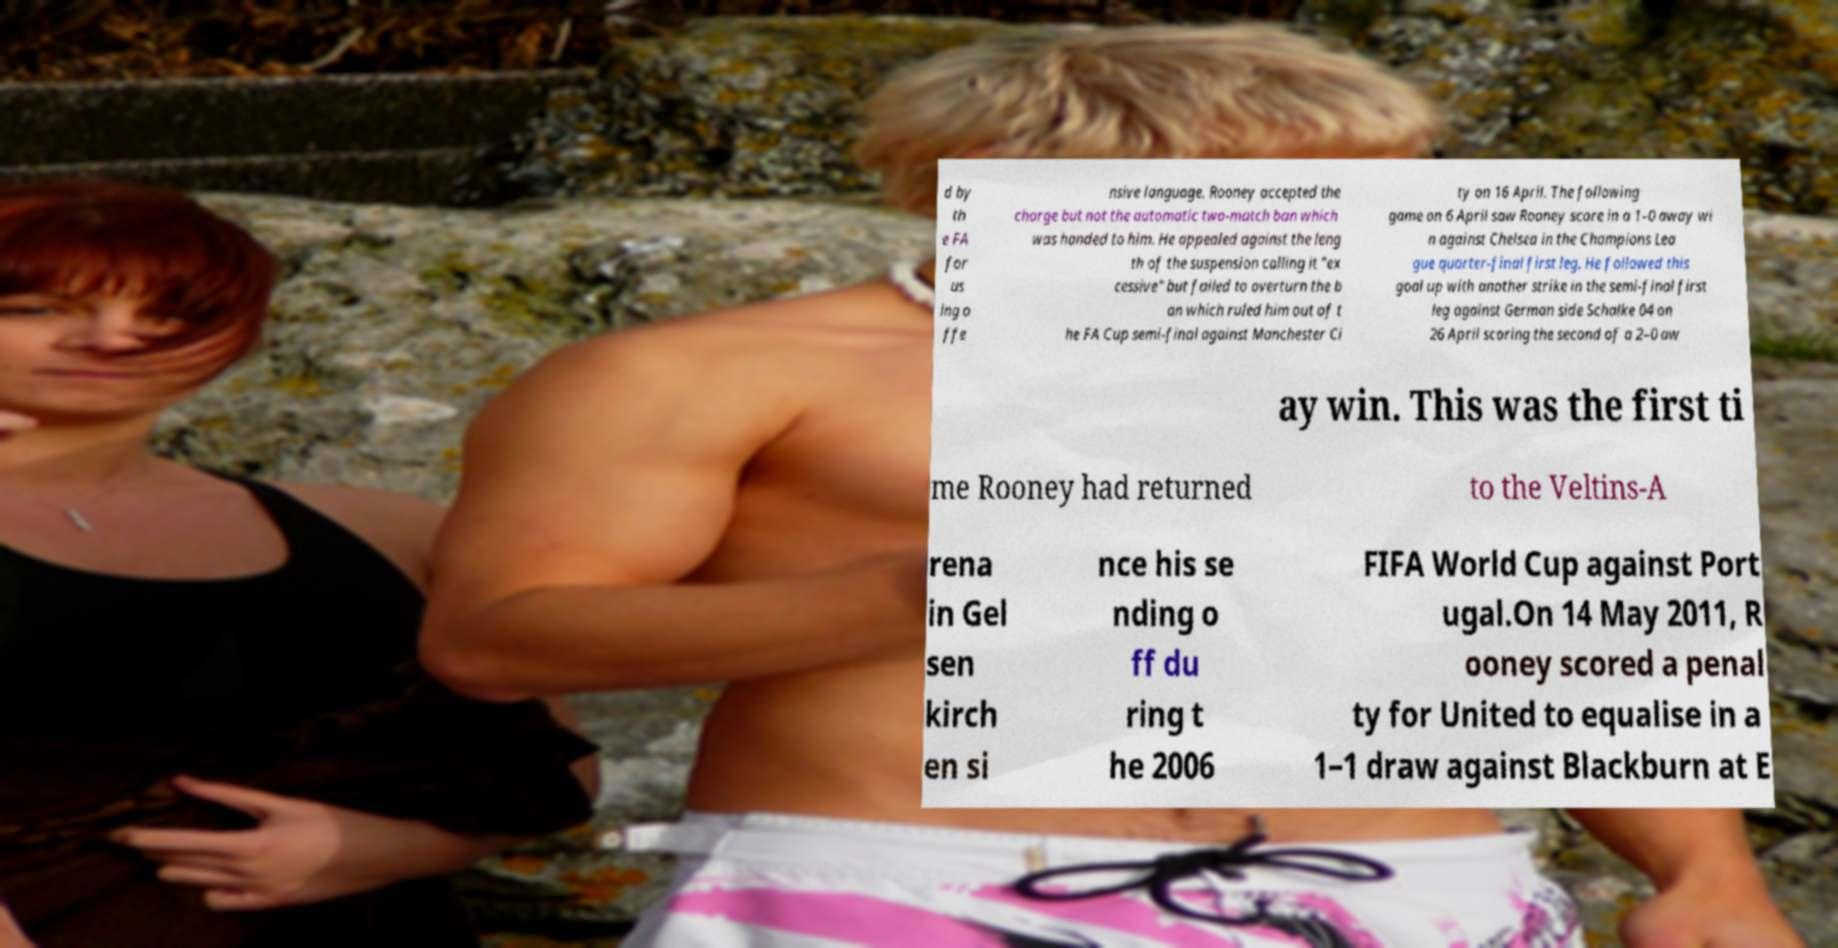Can you read and provide the text displayed in the image?This photo seems to have some interesting text. Can you extract and type it out for me? d by th e FA for us ing o ffe nsive language. Rooney accepted the charge but not the automatic two-match ban which was handed to him. He appealed against the leng th of the suspension calling it "ex cessive" but failed to overturn the b an which ruled him out of t he FA Cup semi-final against Manchester Ci ty on 16 April. The following game on 6 April saw Rooney score in a 1–0 away wi n against Chelsea in the Champions Lea gue quarter-final first leg. He followed this goal up with another strike in the semi-final first leg against German side Schalke 04 on 26 April scoring the second of a 2–0 aw ay win. This was the first ti me Rooney had returned to the Veltins-A rena in Gel sen kirch en si nce his se nding o ff du ring t he 2006 FIFA World Cup against Port ugal.On 14 May 2011, R ooney scored a penal ty for United to equalise in a 1–1 draw against Blackburn at E 